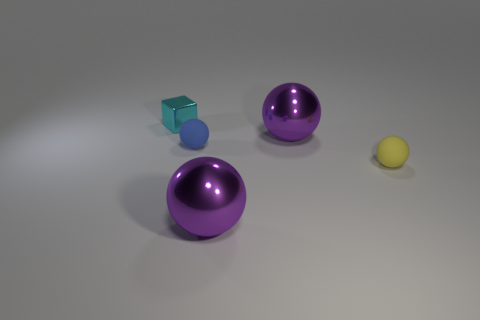Is there anything else that has the same size as the cyan shiny thing?
Keep it short and to the point. Yes. Do the cube and the yellow thing have the same material?
Keep it short and to the point. No. Is the tiny cyan block made of the same material as the tiny ball that is behind the small yellow object?
Your answer should be very brief. No. What is the color of the rubber ball right of the purple object that is behind the blue thing?
Your answer should be very brief. Yellow. Are there the same number of cyan metallic objects right of the small cyan thing and large cyan matte cylinders?
Provide a succinct answer. Yes. Is there another cyan cube that has the same size as the shiny cube?
Your answer should be very brief. No. Do the yellow rubber sphere and the rubber thing that is behind the yellow object have the same size?
Offer a terse response. Yes. Is the number of tiny yellow rubber spheres in front of the tiny yellow thing the same as the number of tiny yellow things that are in front of the cyan shiny block?
Your answer should be compact. No. What material is the purple ball in front of the blue matte object?
Offer a very short reply. Metal. Does the yellow thing have the same size as the cyan block?
Offer a very short reply. Yes. 